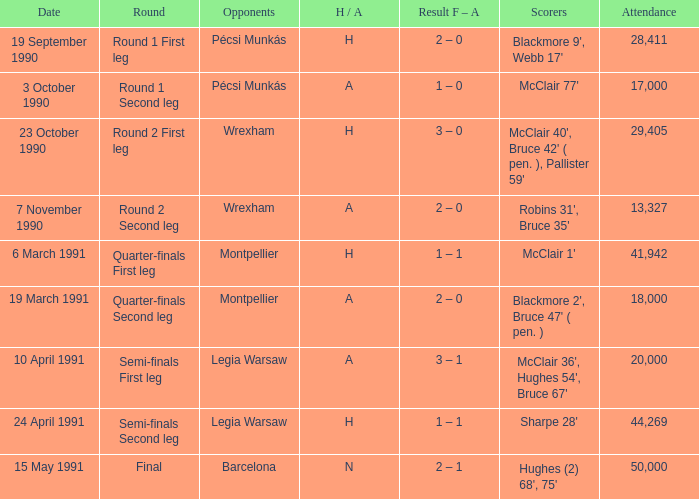What was the attendance figure for the final round? 50000.0. 